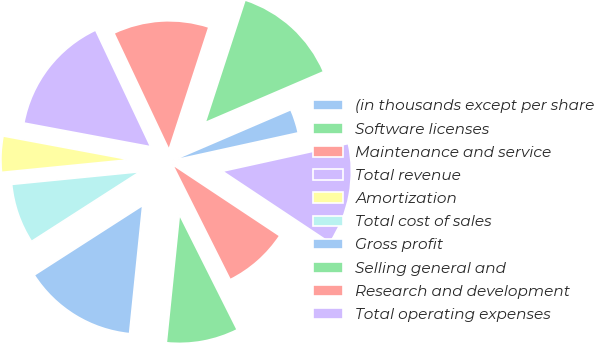<chart> <loc_0><loc_0><loc_500><loc_500><pie_chart><fcel>(in thousands except per share<fcel>Software licenses<fcel>Maintenance and service<fcel>Total revenue<fcel>Amortization<fcel>Total cost of sales<fcel>Gross profit<fcel>Selling general and<fcel>Research and development<fcel>Total operating expenses<nl><fcel>3.01%<fcel>13.53%<fcel>12.03%<fcel>15.04%<fcel>4.51%<fcel>7.52%<fcel>14.29%<fcel>9.02%<fcel>8.27%<fcel>12.78%<nl></chart> 